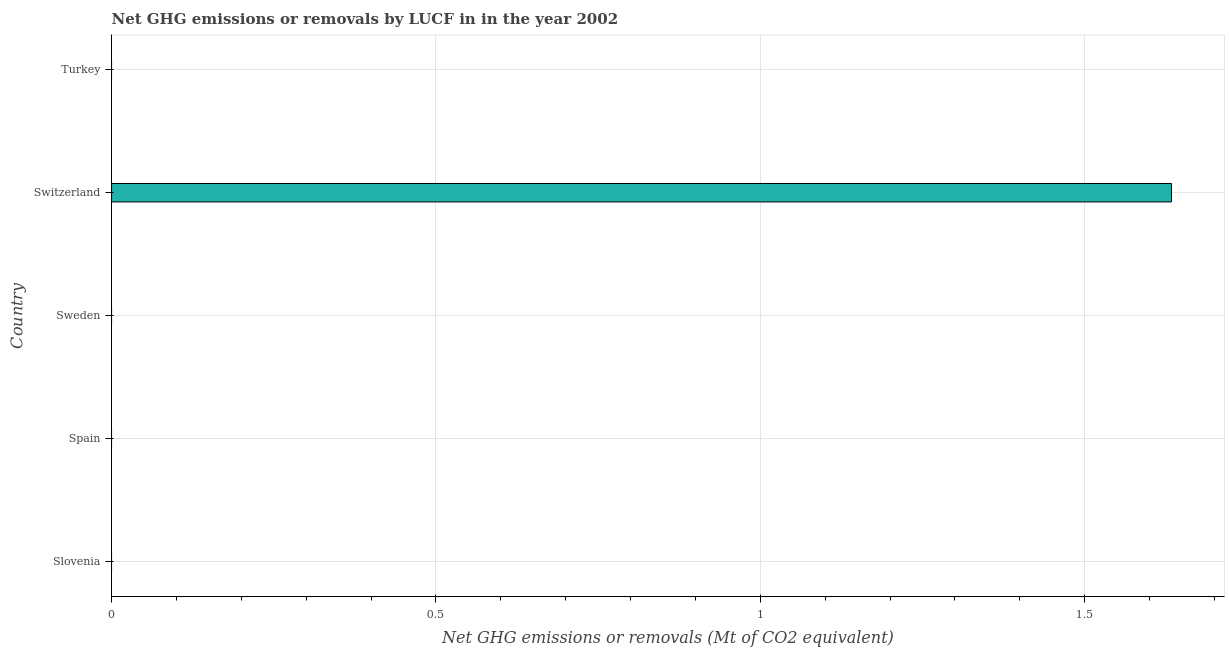What is the title of the graph?
Give a very brief answer. Net GHG emissions or removals by LUCF in in the year 2002. What is the label or title of the X-axis?
Provide a short and direct response. Net GHG emissions or removals (Mt of CO2 equivalent). What is the label or title of the Y-axis?
Offer a very short reply. Country. Across all countries, what is the maximum ghg net emissions or removals?
Your response must be concise. 1.63. In which country was the ghg net emissions or removals maximum?
Your answer should be compact. Switzerland. What is the sum of the ghg net emissions or removals?
Offer a terse response. 1.63. What is the average ghg net emissions or removals per country?
Provide a succinct answer. 0.33. What is the median ghg net emissions or removals?
Provide a succinct answer. 0. What is the difference between the highest and the lowest ghg net emissions or removals?
Make the answer very short. 1.63. How many bars are there?
Give a very brief answer. 1. Are all the bars in the graph horizontal?
Provide a succinct answer. Yes. How many countries are there in the graph?
Offer a terse response. 5. Are the values on the major ticks of X-axis written in scientific E-notation?
Ensure brevity in your answer.  No. What is the Net GHG emissions or removals (Mt of CO2 equivalent) of Slovenia?
Your response must be concise. 0. What is the Net GHG emissions or removals (Mt of CO2 equivalent) in Spain?
Offer a very short reply. 0. What is the Net GHG emissions or removals (Mt of CO2 equivalent) of Sweden?
Keep it short and to the point. 0. What is the Net GHG emissions or removals (Mt of CO2 equivalent) in Switzerland?
Offer a terse response. 1.63. What is the Net GHG emissions or removals (Mt of CO2 equivalent) of Turkey?
Provide a succinct answer. 0. 